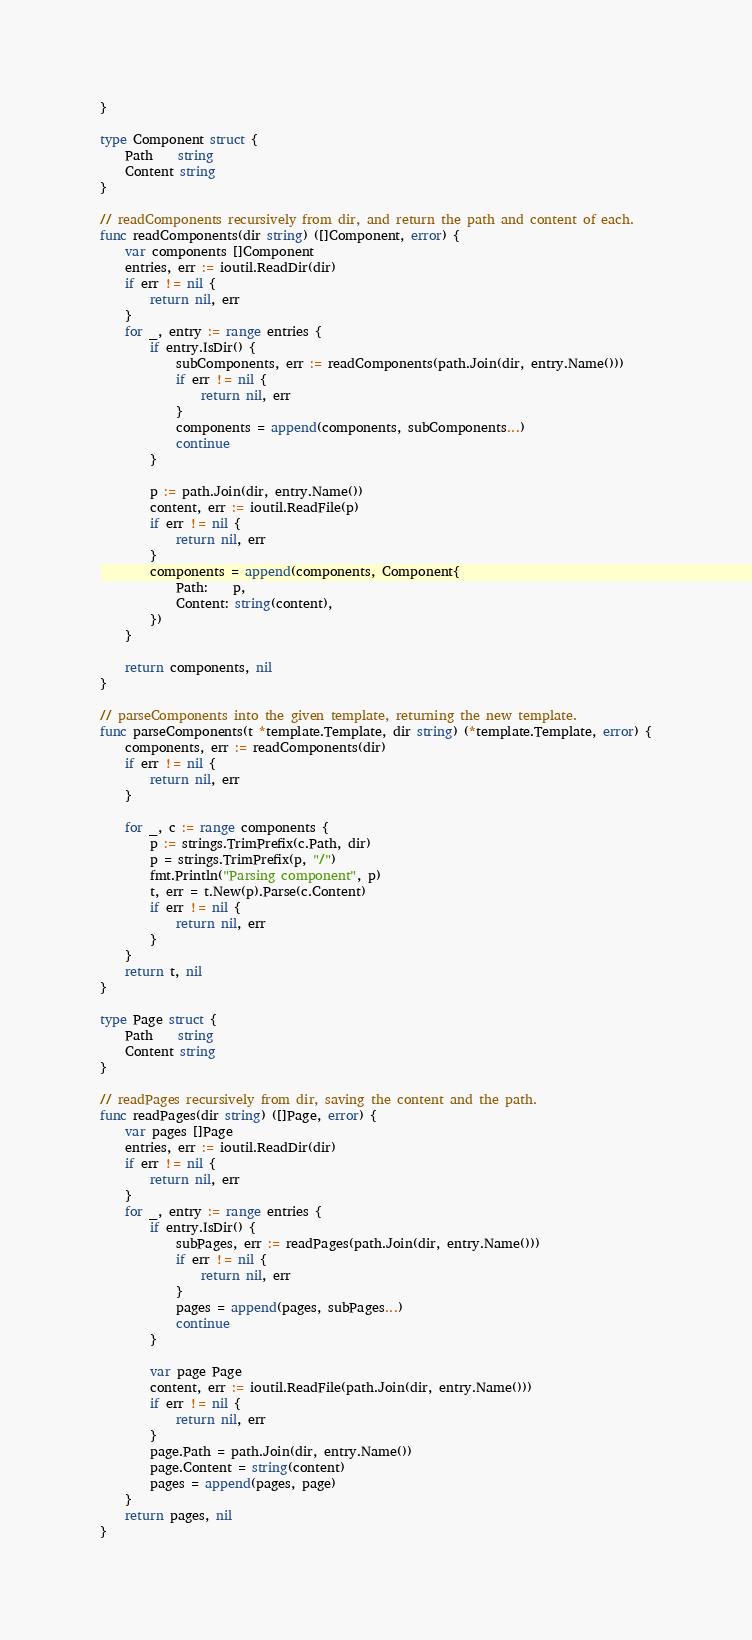Convert code to text. <code><loc_0><loc_0><loc_500><loc_500><_Go_>}

type Component struct {
	Path    string
	Content string
}

// readComponents recursively from dir, and return the path and content of each.
func readComponents(dir string) ([]Component, error) {
	var components []Component
	entries, err := ioutil.ReadDir(dir)
	if err != nil {
		return nil, err
	}
	for _, entry := range entries {
		if entry.IsDir() {
			subComponents, err := readComponents(path.Join(dir, entry.Name()))
			if err != nil {
				return nil, err
			}
			components = append(components, subComponents...)
			continue
		}

		p := path.Join(dir, entry.Name())
		content, err := ioutil.ReadFile(p)
		if err != nil {
			return nil, err
		}
		components = append(components, Component{
			Path:    p,
			Content: string(content),
		})
	}

	return components, nil
}

// parseComponents into the given template, returning the new template.
func parseComponents(t *template.Template, dir string) (*template.Template, error) {
	components, err := readComponents(dir)
	if err != nil {
		return nil, err
	}

	for _, c := range components {
		p := strings.TrimPrefix(c.Path, dir)
		p = strings.TrimPrefix(p, "/")
		fmt.Println("Parsing component", p)
		t, err = t.New(p).Parse(c.Content)
		if err != nil {
			return nil, err
		}
	}
	return t, nil
}

type Page struct {
	Path    string
	Content string
}

// readPages recursively from dir, saving the content and the path.
func readPages(dir string) ([]Page, error) {
	var pages []Page
	entries, err := ioutil.ReadDir(dir)
	if err != nil {
		return nil, err
	}
	for _, entry := range entries {
		if entry.IsDir() {
			subPages, err := readPages(path.Join(dir, entry.Name()))
			if err != nil {
				return nil, err
			}
			pages = append(pages, subPages...)
			continue
		}

		var page Page
		content, err := ioutil.ReadFile(path.Join(dir, entry.Name()))
		if err != nil {
			return nil, err
		}
		page.Path = path.Join(dir, entry.Name())
		page.Content = string(content)
		pages = append(pages, page)
	}
	return pages, nil
}
</code> 